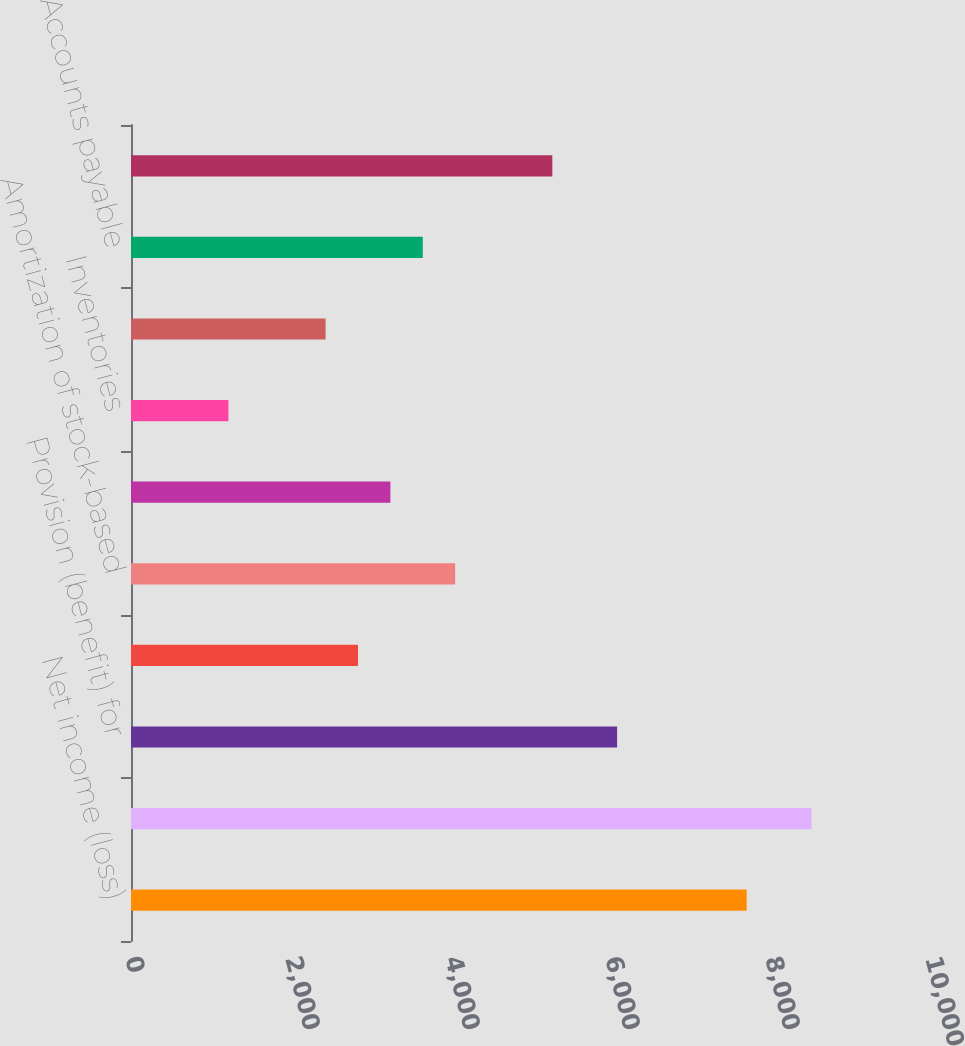Convert chart to OTSL. <chart><loc_0><loc_0><loc_500><loc_500><bar_chart><fcel>Net income (loss)<fcel>Depreciation and amortization<fcel>Provision (benefit) for<fcel>Impairment of and net (gain)<fcel>Amortization of stock-based<fcel>Accounts and notes receivable<fcel>Inventories<fcel>Other current assets and<fcel>Accounts payable<fcel>Accrued liabilities<nl><fcel>7696.1<fcel>8505.9<fcel>6076.5<fcel>2837.3<fcel>4052<fcel>3242.2<fcel>1217.7<fcel>2432.4<fcel>3647.1<fcel>5266.7<nl></chart> 